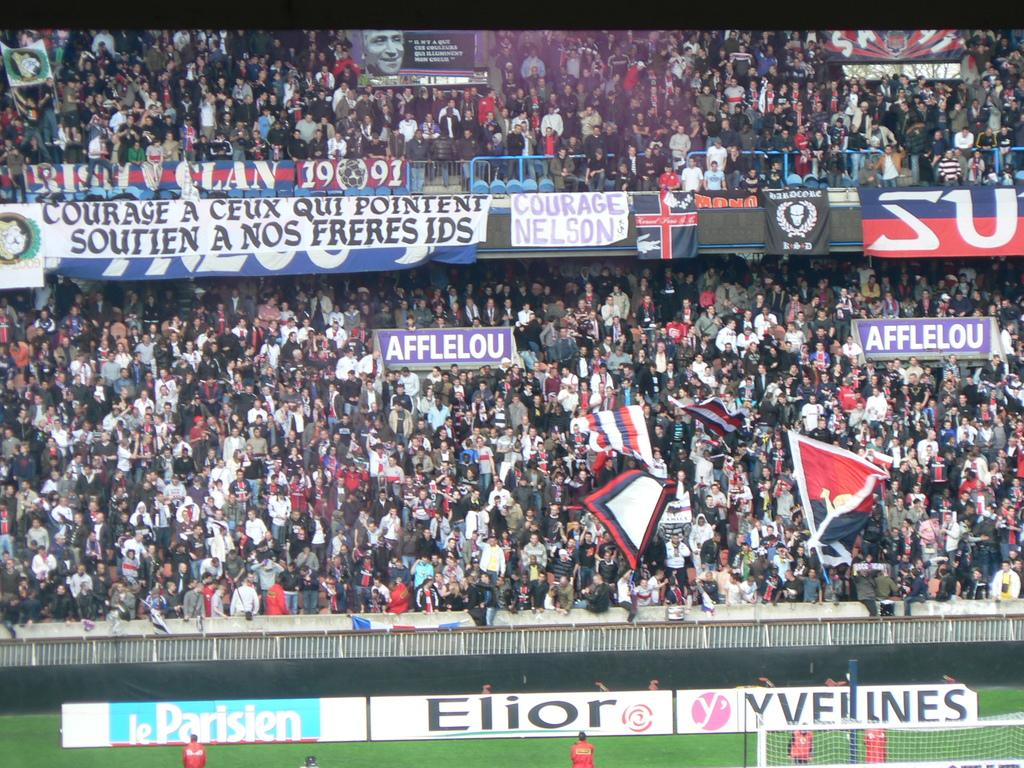<image>
Describe the image concisely. The crowd at a sporting event with logo banners displayed for Elior and other companies. 